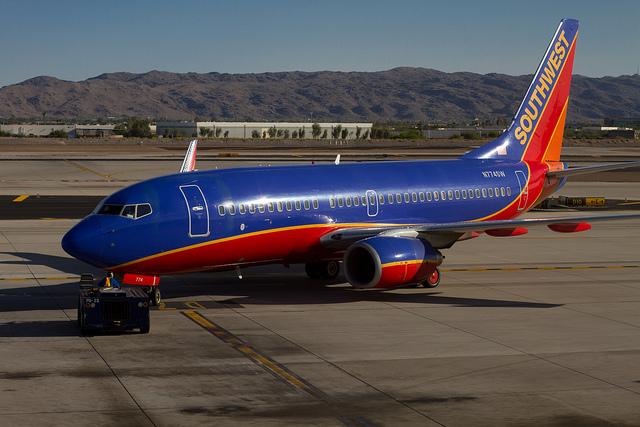Is the plane being towed?
Quick response, please. Yes. What company owns the plane?
Write a very short answer. Southwest. Is this plane flying?
Answer briefly. No. What are the colors of Southwest Airlines?
Quick response, please. Blue and red. How many planes are there?
Write a very short answer. 1. 